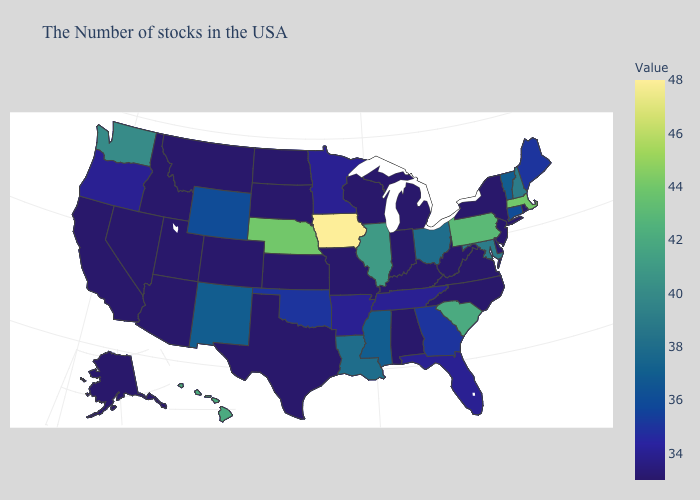Does Iowa have the highest value in the USA?
Concise answer only. Yes. Does Connecticut have the lowest value in the Northeast?
Answer briefly. No. Is the legend a continuous bar?
Concise answer only. Yes. Is the legend a continuous bar?
Quick response, please. Yes. Which states have the highest value in the USA?
Give a very brief answer. Iowa. 